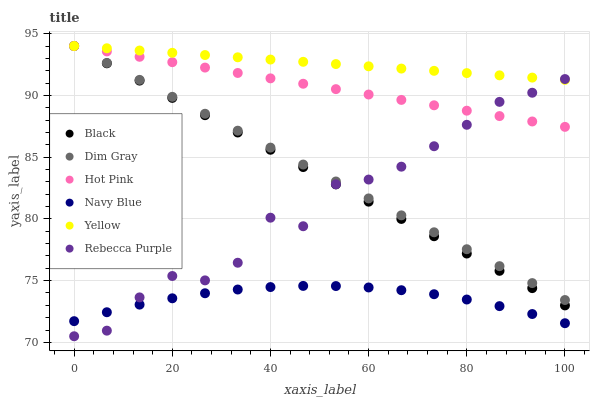Does Navy Blue have the minimum area under the curve?
Answer yes or no. Yes. Does Yellow have the maximum area under the curve?
Answer yes or no. Yes. Does Hot Pink have the minimum area under the curve?
Answer yes or no. No. Does Hot Pink have the maximum area under the curve?
Answer yes or no. No. Is Hot Pink the smoothest?
Answer yes or no. Yes. Is Rebecca Purple the roughest?
Answer yes or no. Yes. Is Navy Blue the smoothest?
Answer yes or no. No. Is Navy Blue the roughest?
Answer yes or no. No. Does Rebecca Purple have the lowest value?
Answer yes or no. Yes. Does Navy Blue have the lowest value?
Answer yes or no. No. Does Black have the highest value?
Answer yes or no. Yes. Does Navy Blue have the highest value?
Answer yes or no. No. Is Navy Blue less than Black?
Answer yes or no. Yes. Is Dim Gray greater than Navy Blue?
Answer yes or no. Yes. Does Yellow intersect Black?
Answer yes or no. Yes. Is Yellow less than Black?
Answer yes or no. No. Is Yellow greater than Black?
Answer yes or no. No. Does Navy Blue intersect Black?
Answer yes or no. No. 